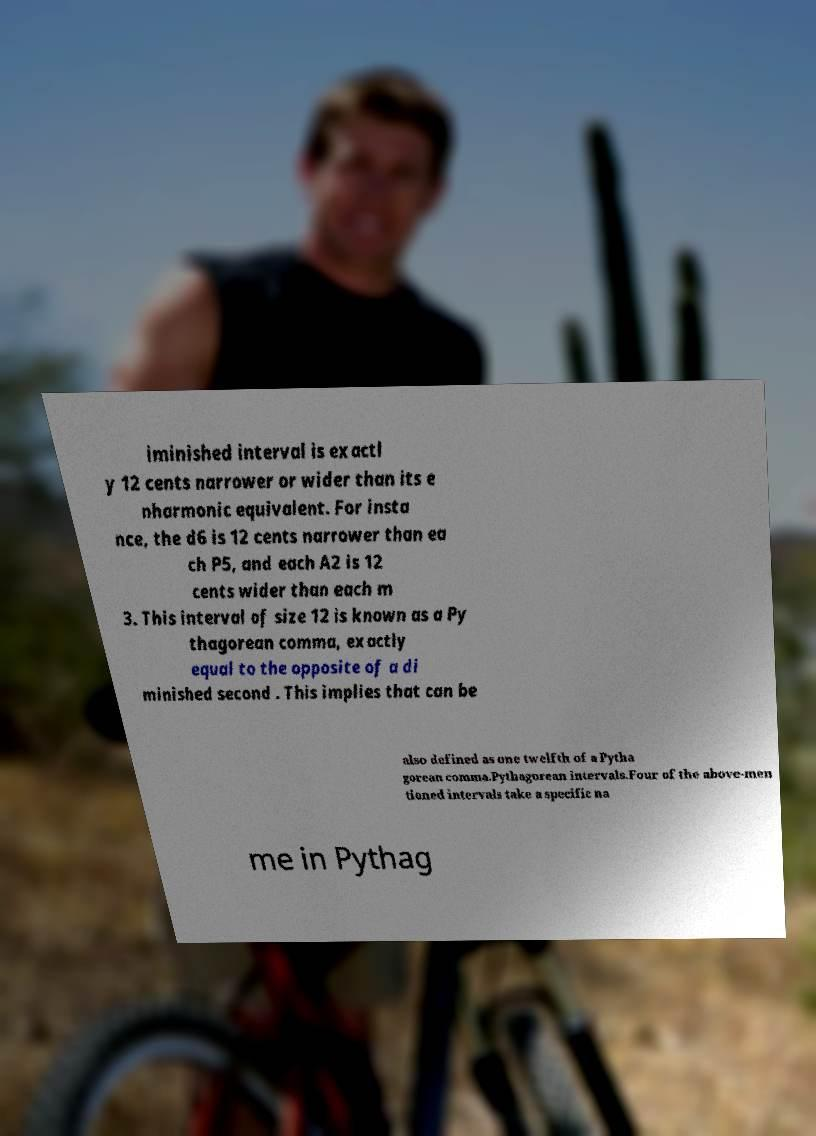Please identify and transcribe the text found in this image. iminished interval is exactl y 12 cents narrower or wider than its e nharmonic equivalent. For insta nce, the d6 is 12 cents narrower than ea ch P5, and each A2 is 12 cents wider than each m 3. This interval of size 12 is known as a Py thagorean comma, exactly equal to the opposite of a di minished second . This implies that can be also defined as one twelfth of a Pytha gorean comma.Pythagorean intervals.Four of the above-men tioned intervals take a specific na me in Pythag 